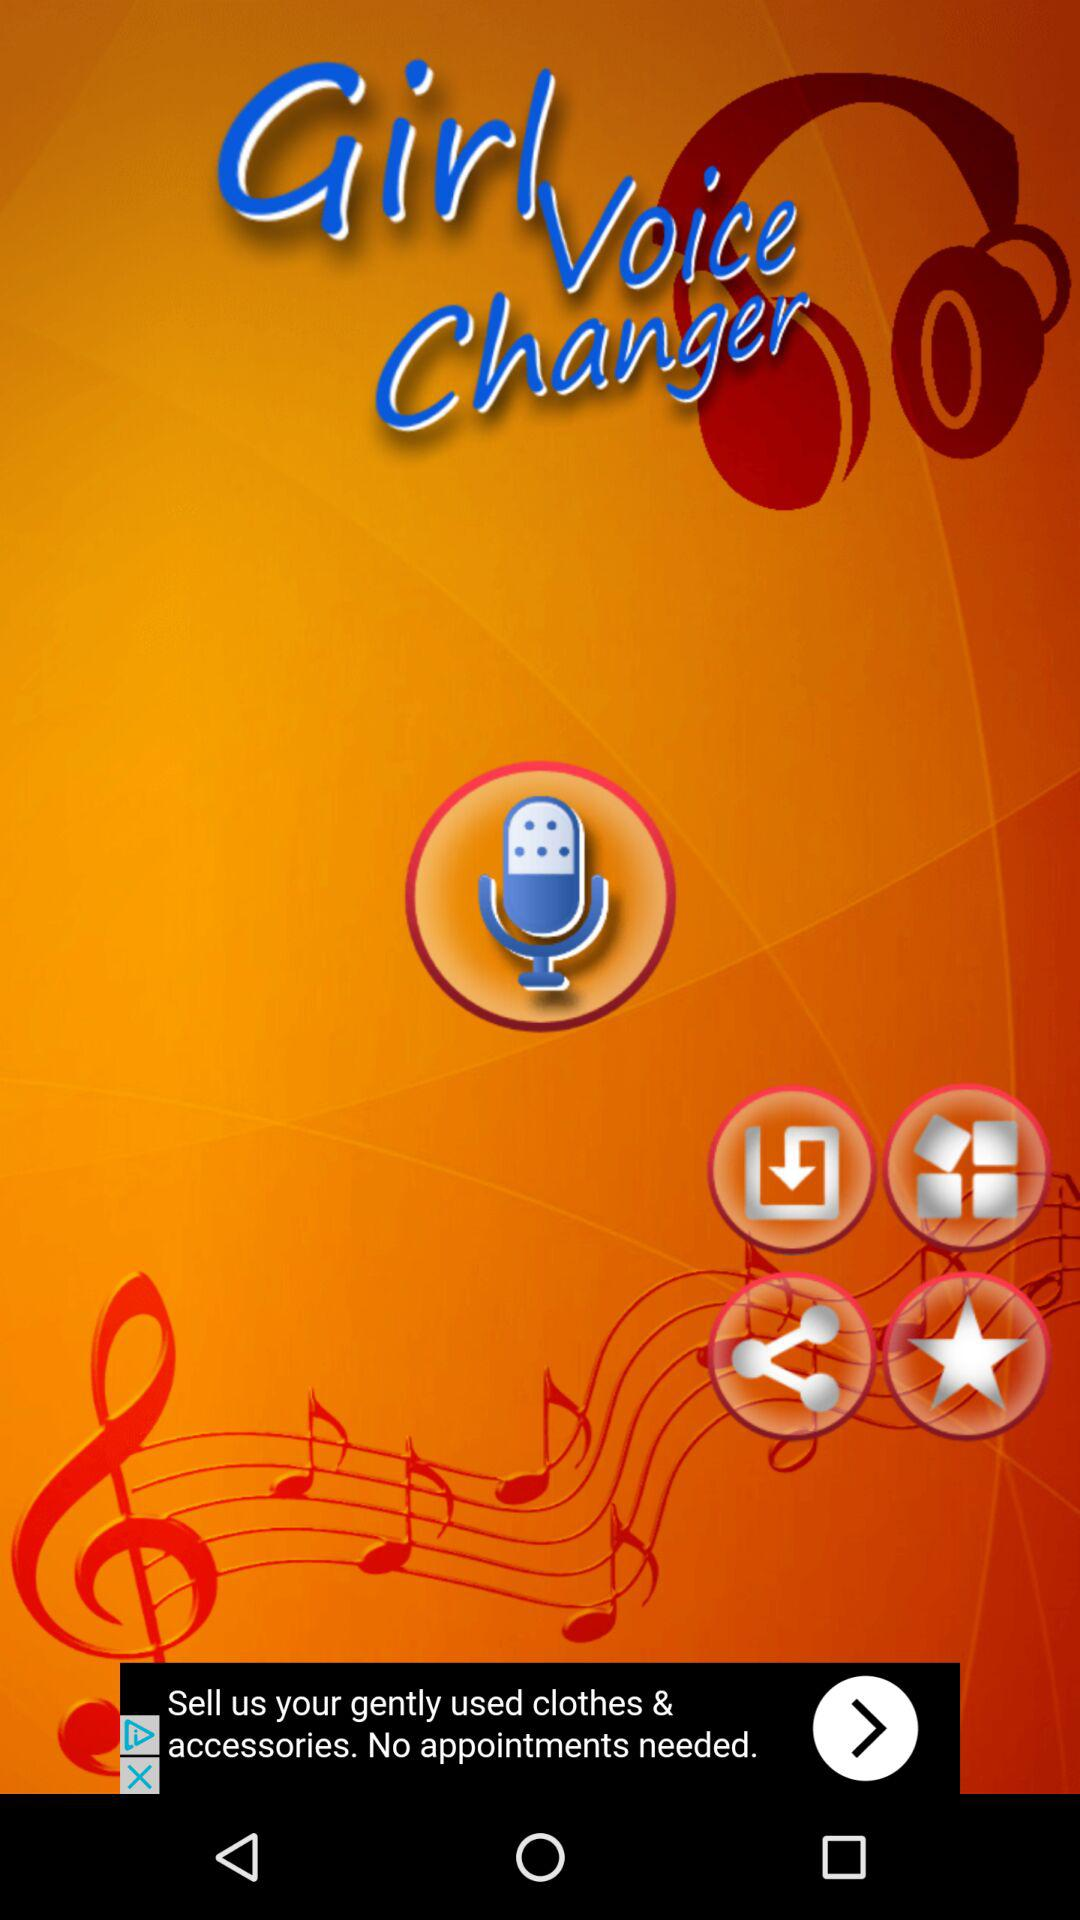What is the name of the application? The name of the application is "Girl Voice Changer". 